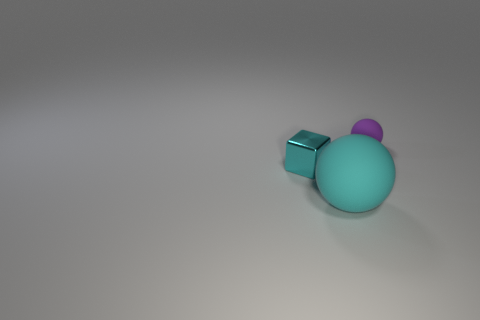Add 1 spheres. How many objects exist? 4 Subtract all purple balls. How many balls are left? 1 Subtract all spheres. How many objects are left? 1 Subtract all green blocks. Subtract all purple cylinders. How many blocks are left? 1 Subtract all red blocks. How many cyan balls are left? 1 Subtract all cubes. Subtract all small cyan blocks. How many objects are left? 1 Add 1 large spheres. How many large spheres are left? 2 Add 2 small gray cylinders. How many small gray cylinders exist? 2 Subtract 1 cyan cubes. How many objects are left? 2 